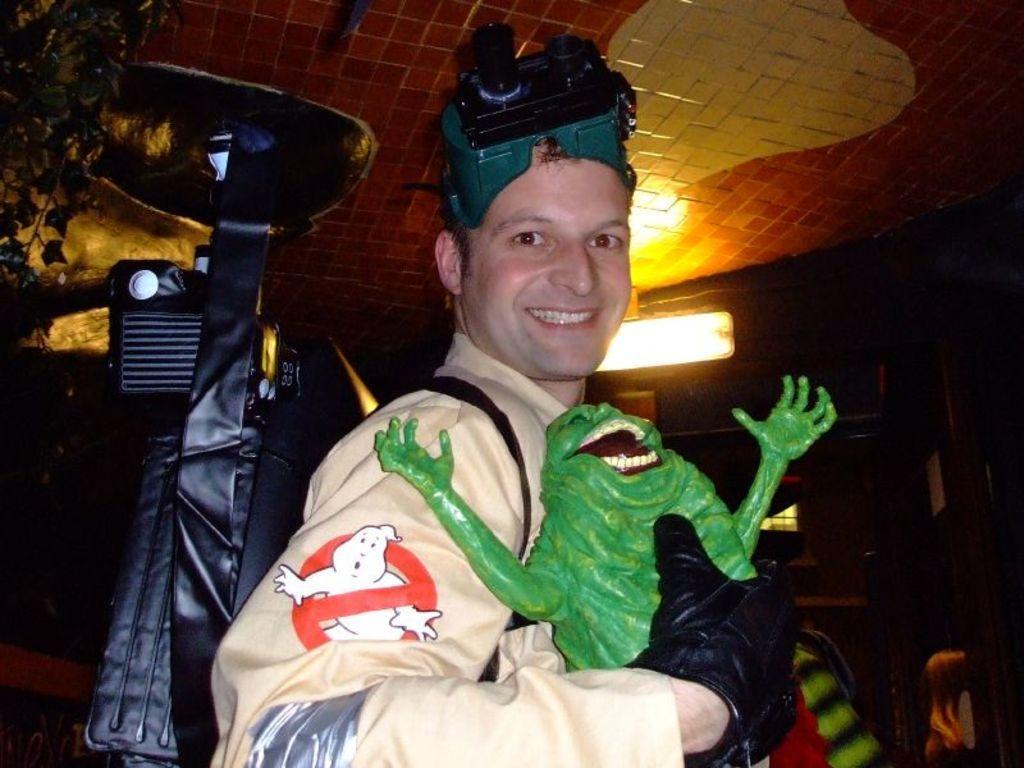Please provide a concise description of this image. In this image I can see a man, I can see he is wearing cream colour dress, black glove, a green colour thing on his head and I can see smile on his face. I can also see he is holding a green colour thing. In the background I can see a plant, a light, few other stuffs and I can see this image is little bit in dark from background. 